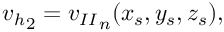Convert formula to latex. <formula><loc_0><loc_0><loc_500><loc_500>\begin{array} { r } { { v _ { h } } _ { 2 } = { v _ { I I } } _ { n } ( x _ { s } , y _ { s } , z _ { s } ) , } \end{array}</formula> 